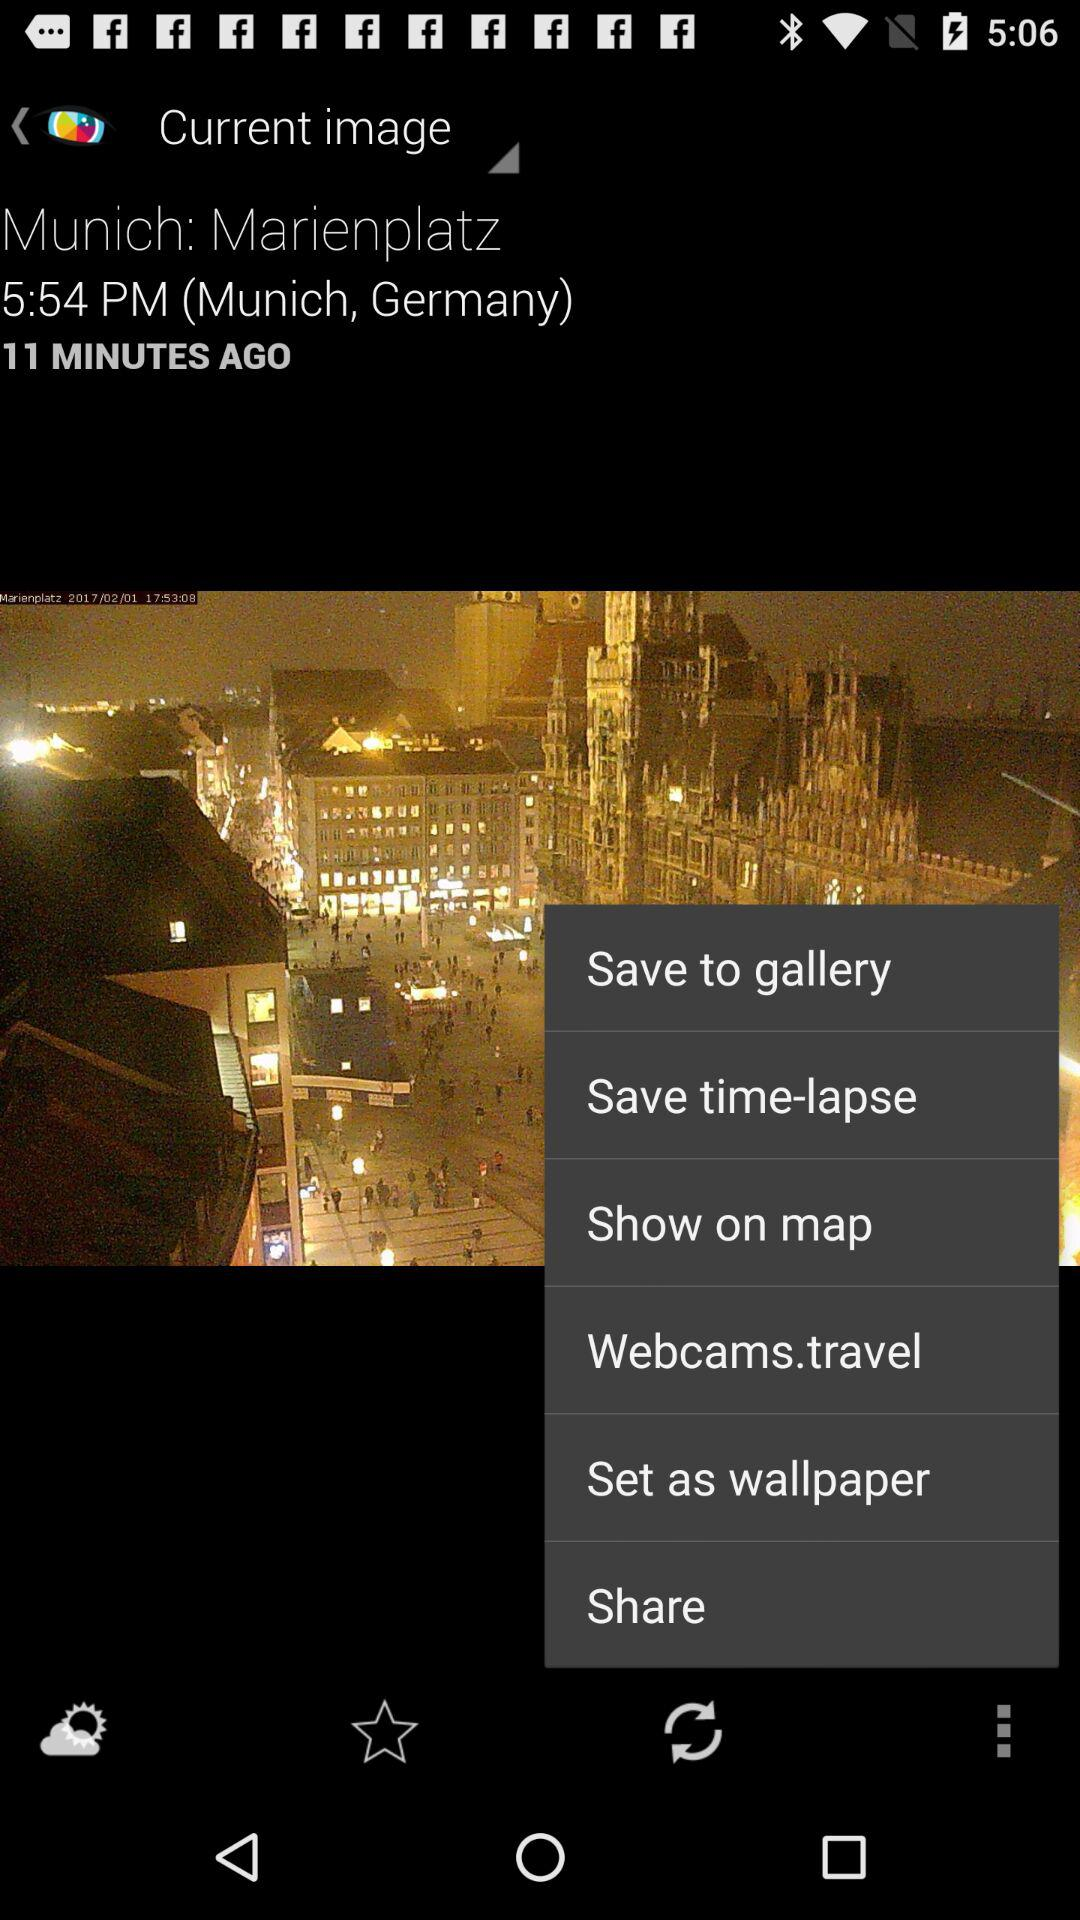At what location was the image captured? The image was captured at Marienplatz in Munich, Germany. 